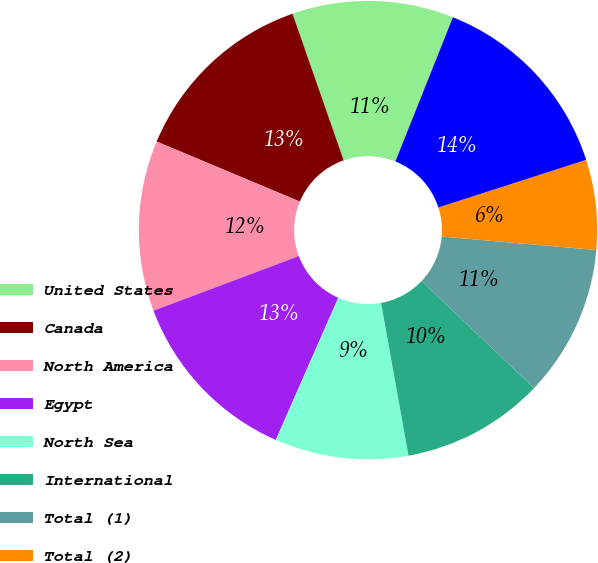<chart> <loc_0><loc_0><loc_500><loc_500><pie_chart><fcel>United States<fcel>Canada<fcel>North America<fcel>Egypt<fcel>North Sea<fcel>International<fcel>Total (1)<fcel>Total (2)<fcel>Total<nl><fcel>11.38%<fcel>13.34%<fcel>12.03%<fcel>12.69%<fcel>9.41%<fcel>10.07%<fcel>10.72%<fcel>6.34%<fcel>14.0%<nl></chart> 